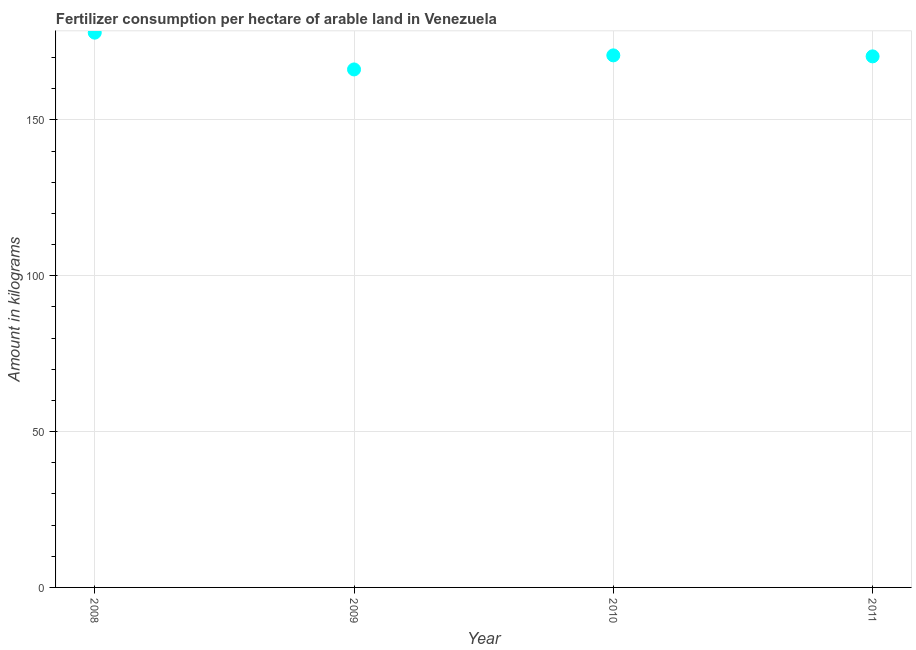What is the amount of fertilizer consumption in 2008?
Your answer should be compact. 177.97. Across all years, what is the maximum amount of fertilizer consumption?
Keep it short and to the point. 177.97. Across all years, what is the minimum amount of fertilizer consumption?
Offer a very short reply. 166.18. In which year was the amount of fertilizer consumption maximum?
Your answer should be very brief. 2008. In which year was the amount of fertilizer consumption minimum?
Keep it short and to the point. 2009. What is the sum of the amount of fertilizer consumption?
Make the answer very short. 685.21. What is the difference between the amount of fertilizer consumption in 2009 and 2011?
Offer a terse response. -4.19. What is the average amount of fertilizer consumption per year?
Keep it short and to the point. 171.3. What is the median amount of fertilizer consumption?
Provide a short and direct response. 170.53. What is the ratio of the amount of fertilizer consumption in 2008 to that in 2009?
Your response must be concise. 1.07. What is the difference between the highest and the second highest amount of fertilizer consumption?
Offer a very short reply. 7.29. What is the difference between the highest and the lowest amount of fertilizer consumption?
Your answer should be very brief. 11.8. In how many years, is the amount of fertilizer consumption greater than the average amount of fertilizer consumption taken over all years?
Ensure brevity in your answer.  1. How many dotlines are there?
Ensure brevity in your answer.  1. How many years are there in the graph?
Provide a short and direct response. 4. What is the difference between two consecutive major ticks on the Y-axis?
Provide a short and direct response. 50. Does the graph contain grids?
Ensure brevity in your answer.  Yes. What is the title of the graph?
Provide a short and direct response. Fertilizer consumption per hectare of arable land in Venezuela . What is the label or title of the X-axis?
Offer a terse response. Year. What is the label or title of the Y-axis?
Ensure brevity in your answer.  Amount in kilograms. What is the Amount in kilograms in 2008?
Your answer should be very brief. 177.97. What is the Amount in kilograms in 2009?
Offer a very short reply. 166.18. What is the Amount in kilograms in 2010?
Your response must be concise. 170.69. What is the Amount in kilograms in 2011?
Keep it short and to the point. 170.37. What is the difference between the Amount in kilograms in 2008 and 2009?
Give a very brief answer. 11.8. What is the difference between the Amount in kilograms in 2008 and 2010?
Offer a very short reply. 7.29. What is the difference between the Amount in kilograms in 2008 and 2011?
Your answer should be very brief. 7.6. What is the difference between the Amount in kilograms in 2009 and 2010?
Offer a terse response. -4.51. What is the difference between the Amount in kilograms in 2009 and 2011?
Offer a terse response. -4.19. What is the difference between the Amount in kilograms in 2010 and 2011?
Your answer should be very brief. 0.32. What is the ratio of the Amount in kilograms in 2008 to that in 2009?
Make the answer very short. 1.07. What is the ratio of the Amount in kilograms in 2008 to that in 2010?
Offer a very short reply. 1.04. What is the ratio of the Amount in kilograms in 2008 to that in 2011?
Keep it short and to the point. 1.04. What is the ratio of the Amount in kilograms in 2010 to that in 2011?
Ensure brevity in your answer.  1. 